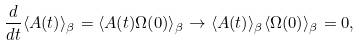<formula> <loc_0><loc_0><loc_500><loc_500>\frac { d } { d t } \langle A ( t ) \rangle _ { \beta } = \langle A ( t ) \Omega ( 0 ) \rangle _ { \beta } \to \langle A ( t ) \rangle _ { \beta } \langle \Omega ( 0 ) \rangle _ { \beta } = 0 ,</formula> 